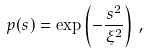<formula> <loc_0><loc_0><loc_500><loc_500>p ( s ) = \exp \left ( - \frac { s ^ { 2 } } { \xi ^ { 2 } } \right ) \, ,</formula> 